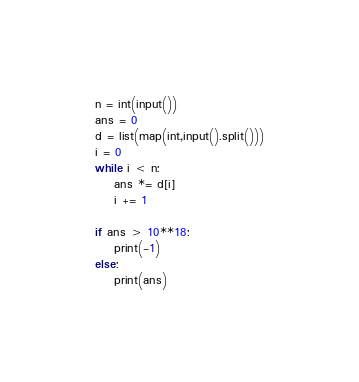Convert code to text. <code><loc_0><loc_0><loc_500><loc_500><_Python_>n = int(input())
ans = 0
d = list(map(int,input().split()))
i = 0
while i < n:
    ans *= d[i]
    i += 1

if ans > 10**18:
    print(-1)
else:
    print(ans)</code> 